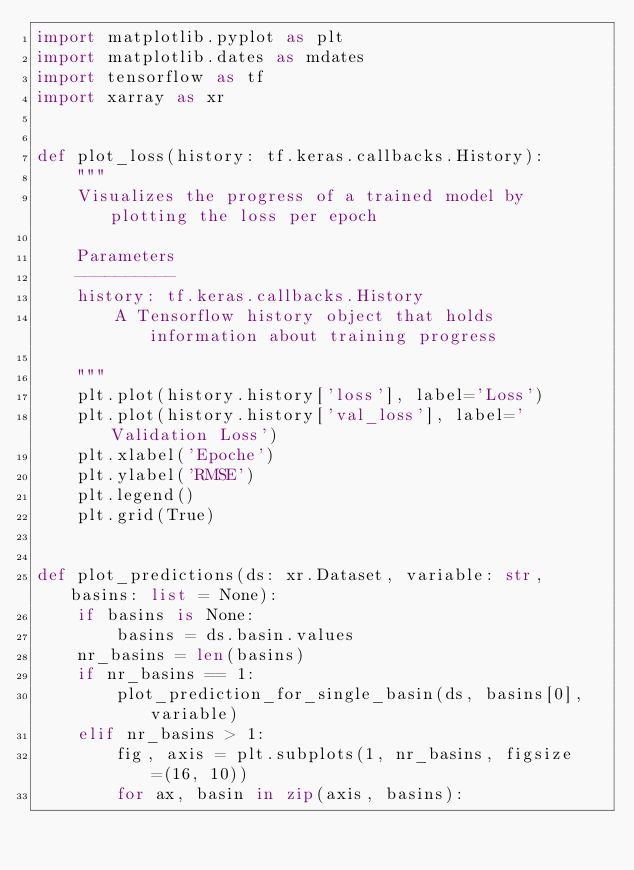Convert code to text. <code><loc_0><loc_0><loc_500><loc_500><_Python_>import matplotlib.pyplot as plt
import matplotlib.dates as mdates
import tensorflow as tf
import xarray as xr


def plot_loss(history: tf.keras.callbacks.History):
    """
    Visualizes the progress of a trained model by plotting the loss per epoch

    Parameters
    ----------
    history: tf.keras.callbacks.History
        A Tensorflow history object that holds information about training progress

    """
    plt.plot(history.history['loss'], label='Loss')
    plt.plot(history.history['val_loss'], label='Validation Loss')
    plt.xlabel('Epoche')
    plt.ylabel('RMSE')
    plt.legend()
    plt.grid(True)


def plot_predictions(ds: xr.Dataset, variable: str, basins: list = None):
    if basins is None:
        basins = ds.basin.values
    nr_basins = len(basins)
    if nr_basins == 1:
        plot_prediction_for_single_basin(ds, basins[0], variable)
    elif nr_basins > 1:
        fig, axis = plt.subplots(1, nr_basins, figsize=(16, 10))
        for ax, basin in zip(axis, basins):</code> 